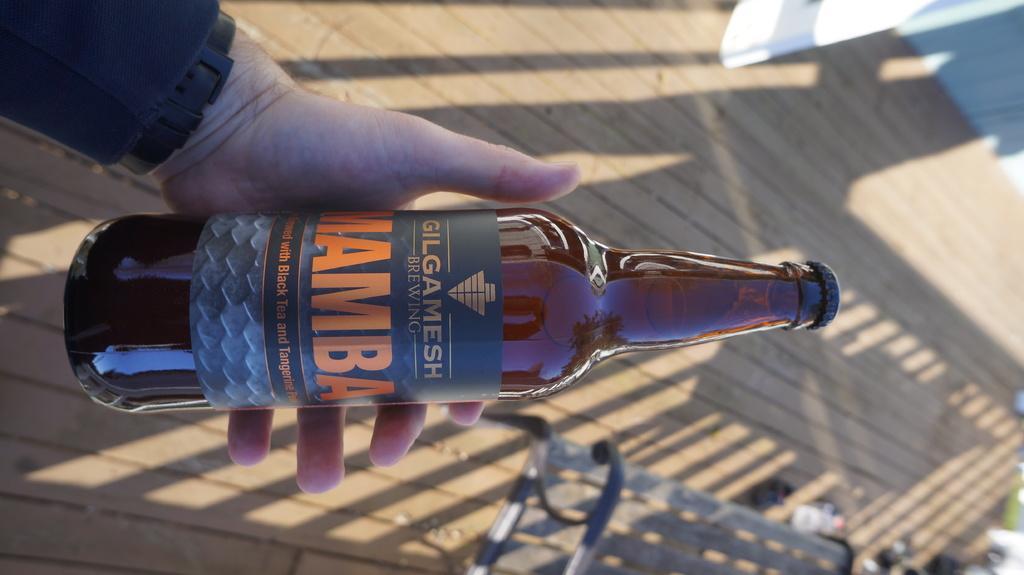Could you give a brief overview of what you see in this image? In this image I can see the person holding the bottle. To the right I can see the bench. In the background I can see the wooden floor. 